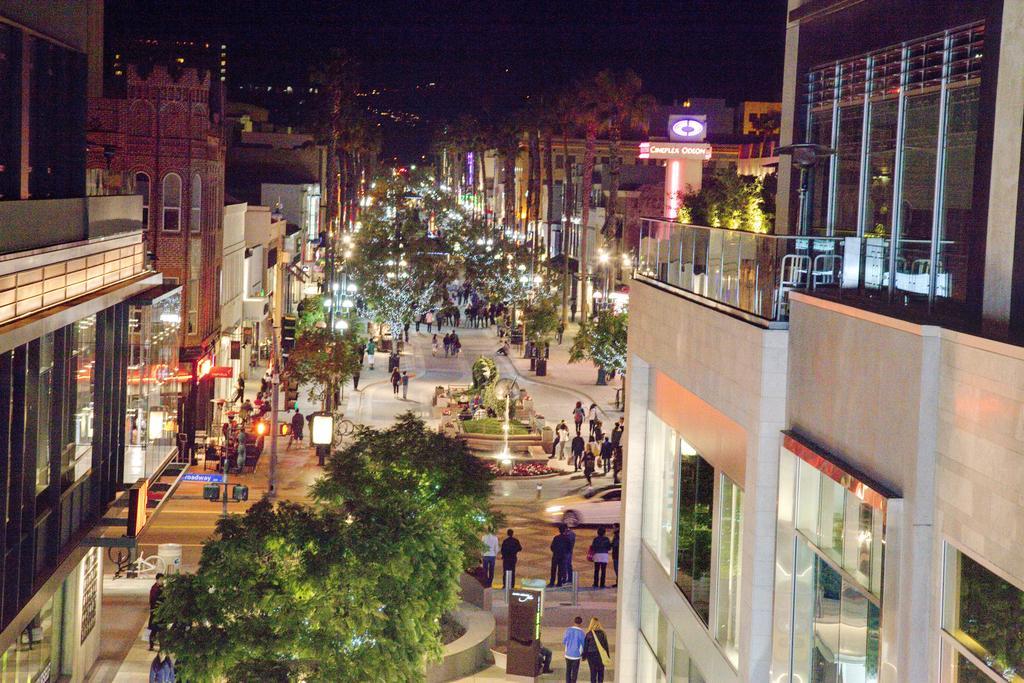How would you summarize this image in a sentence or two? In the foreground of this image, on either side, there are buildings. At the bottom, there are trees and people walking and standing on the pavement. In the background, there are buildings, trees, lights, few poles, fountain and people walking on the pavement. At the top, there is the dark sky. 